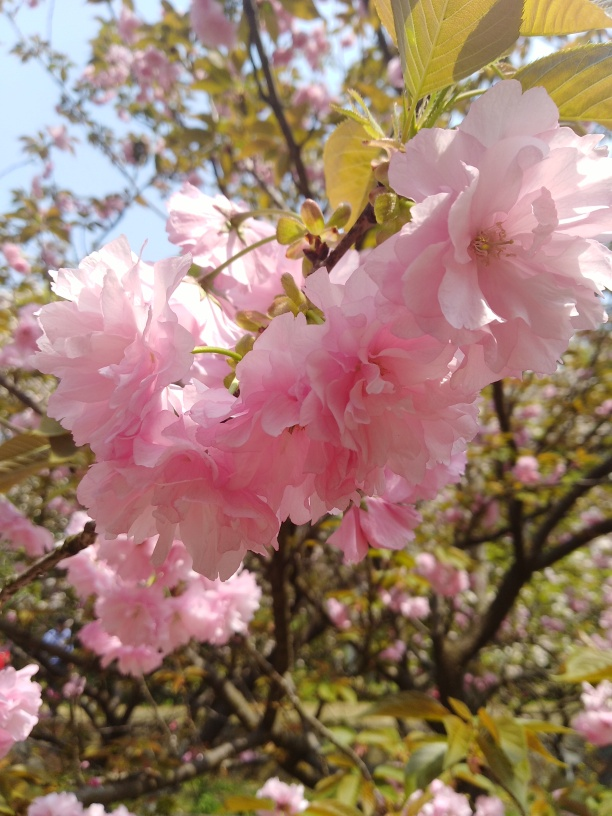Are the colors vibrant? Indeed, the colors are vibrant. The pink hues of the cherry blossoms gleam with a soft yet lively saturation, complementing the delicate nuances within each petal. The image captures the essence of spring with its brightness and the vivid contrast against the backdrop of the clear blue sky. 